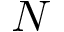Convert formula to latex. <formula><loc_0><loc_0><loc_500><loc_500>N</formula> 